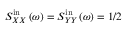Convert formula to latex. <formula><loc_0><loc_0><loc_500><loc_500>S _ { X X } ^ { i n } \left ( \omega \right ) = S _ { Y Y } ^ { i n } \left ( \omega \right ) = 1 / 2</formula> 